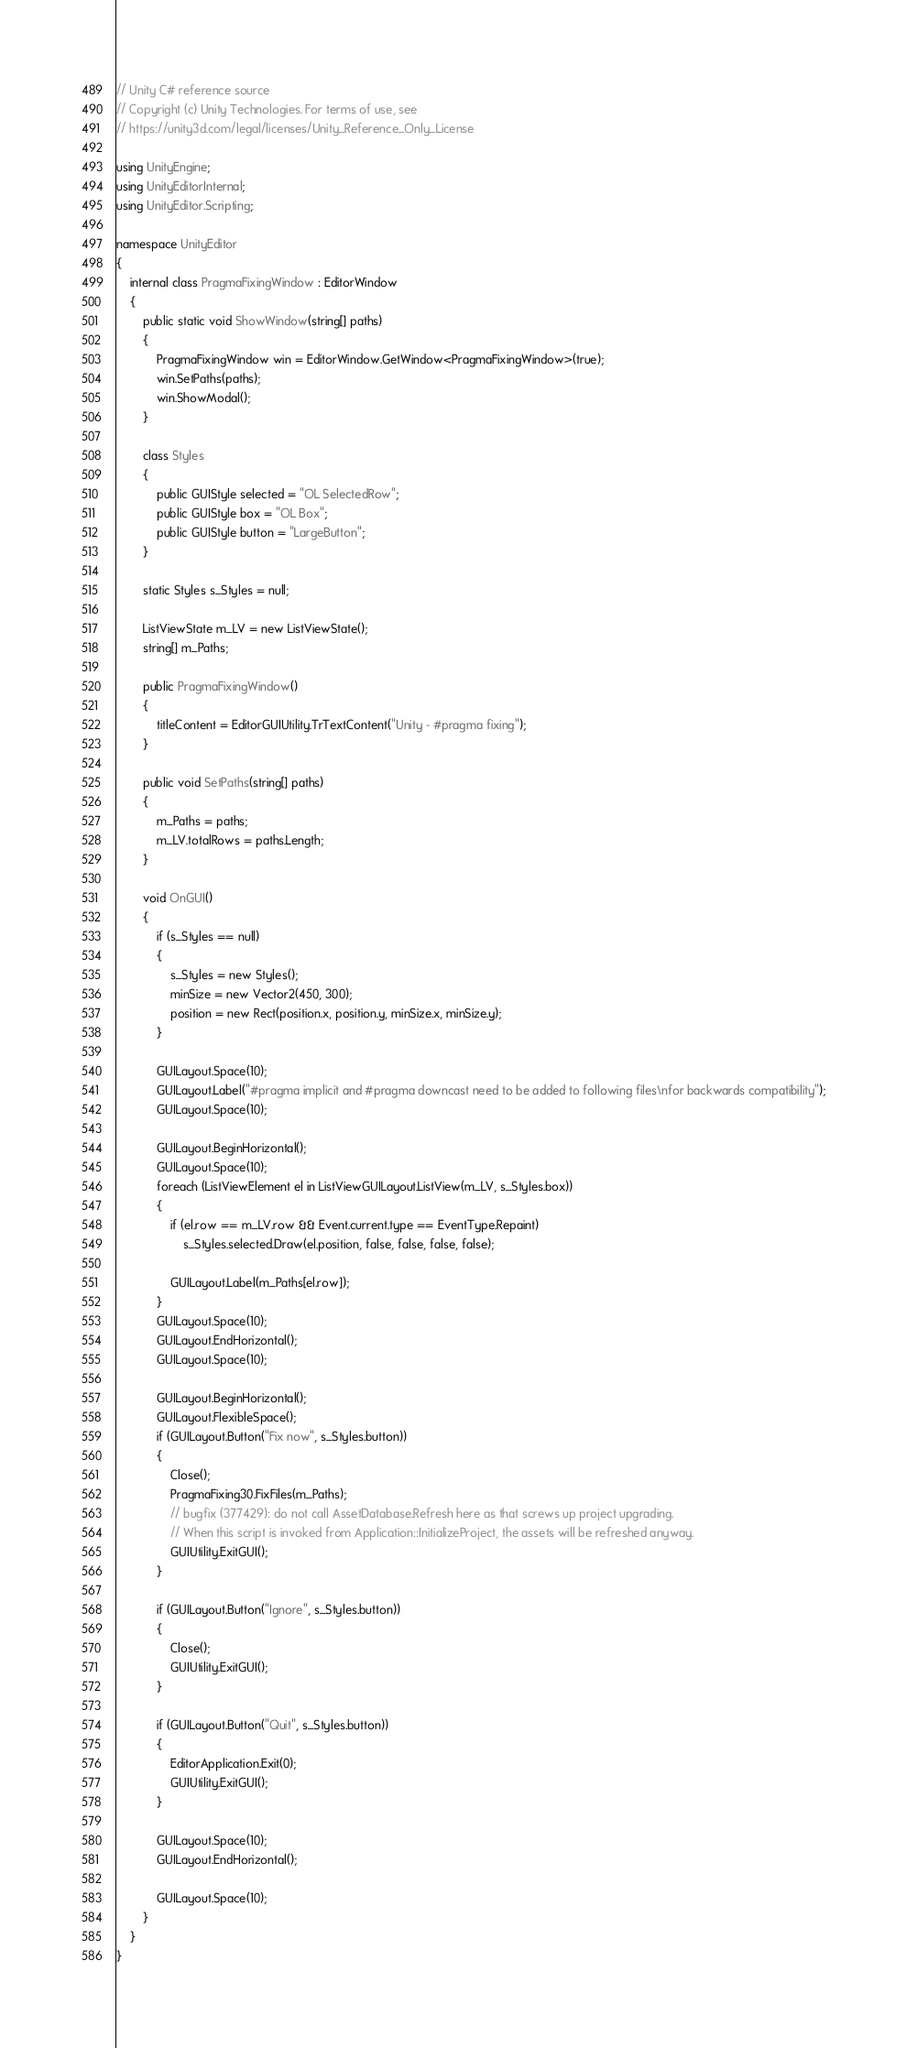<code> <loc_0><loc_0><loc_500><loc_500><_C#_>// Unity C# reference source
// Copyright (c) Unity Technologies. For terms of use, see
// https://unity3d.com/legal/licenses/Unity_Reference_Only_License

using UnityEngine;
using UnityEditorInternal;
using UnityEditor.Scripting;

namespace UnityEditor
{
    internal class PragmaFixingWindow : EditorWindow
    {
        public static void ShowWindow(string[] paths)
        {
            PragmaFixingWindow win = EditorWindow.GetWindow<PragmaFixingWindow>(true);
            win.SetPaths(paths);
            win.ShowModal();
        }

        class Styles
        {
            public GUIStyle selected = "OL SelectedRow";
            public GUIStyle box = "OL Box";
            public GUIStyle button = "LargeButton";
        }

        static Styles s_Styles = null;

        ListViewState m_LV = new ListViewState();
        string[] m_Paths;

        public PragmaFixingWindow()
        {
            titleContent = EditorGUIUtility.TrTextContent("Unity - #pragma fixing");
        }

        public void SetPaths(string[] paths)
        {
            m_Paths = paths;
            m_LV.totalRows = paths.Length;
        }

        void OnGUI()
        {
            if (s_Styles == null)
            {
                s_Styles = new Styles();
                minSize = new Vector2(450, 300);
                position = new Rect(position.x, position.y, minSize.x, minSize.y);
            }

            GUILayout.Space(10);
            GUILayout.Label("#pragma implicit and #pragma downcast need to be added to following files\nfor backwards compatibility");
            GUILayout.Space(10);

            GUILayout.BeginHorizontal();
            GUILayout.Space(10);
            foreach (ListViewElement el in ListViewGUILayout.ListView(m_LV, s_Styles.box))
            {
                if (el.row == m_LV.row && Event.current.type == EventType.Repaint)
                    s_Styles.selected.Draw(el.position, false, false, false, false);

                GUILayout.Label(m_Paths[el.row]);
            }
            GUILayout.Space(10);
            GUILayout.EndHorizontal();
            GUILayout.Space(10);

            GUILayout.BeginHorizontal();
            GUILayout.FlexibleSpace();
            if (GUILayout.Button("Fix now", s_Styles.button))
            {
                Close();
                PragmaFixing30.FixFiles(m_Paths);
                // bugfix (377429): do not call AssetDatabase.Refresh here as that screws up project upgrading.
                // When this script is invoked from Application::InitializeProject, the assets will be refreshed anyway.
                GUIUtility.ExitGUI();
            }

            if (GUILayout.Button("Ignore", s_Styles.button))
            {
                Close();
                GUIUtility.ExitGUI();
            }

            if (GUILayout.Button("Quit", s_Styles.button))
            {
                EditorApplication.Exit(0);
                GUIUtility.ExitGUI();
            }

            GUILayout.Space(10);
            GUILayout.EndHorizontal();

            GUILayout.Space(10);
        }
    }
}
</code> 